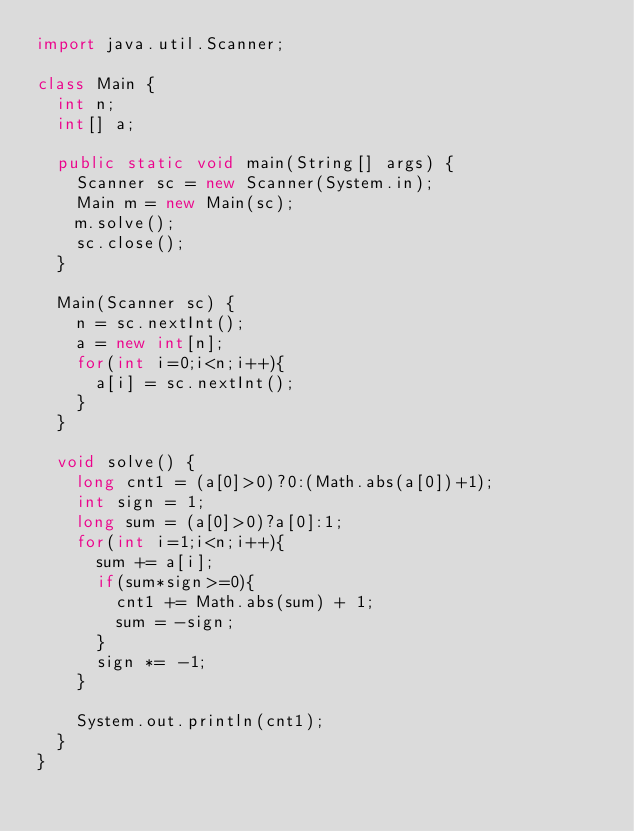<code> <loc_0><loc_0><loc_500><loc_500><_Java_>import java.util.Scanner;

class Main {
	int n;
	int[] a;

	public static void main(String[] args) {
		Scanner sc = new Scanner(System.in);
		Main m = new Main(sc);
		m.solve();
		sc.close();
	}

	Main(Scanner sc) {
		n = sc.nextInt();
		a = new int[n];
		for(int i=0;i<n;i++){
			a[i] = sc.nextInt();
		}
	}

	void solve() {
		long cnt1 = (a[0]>0)?0:(Math.abs(a[0])+1);
		int sign = 1;
		long sum = (a[0]>0)?a[0]:1;
		for(int i=1;i<n;i++){
			sum += a[i];
			if(sum*sign>=0){
				cnt1 += Math.abs(sum) + 1;
				sum = -sign;
			}
			sign *= -1;
		}

		System.out.println(cnt1);
	}
}</code> 